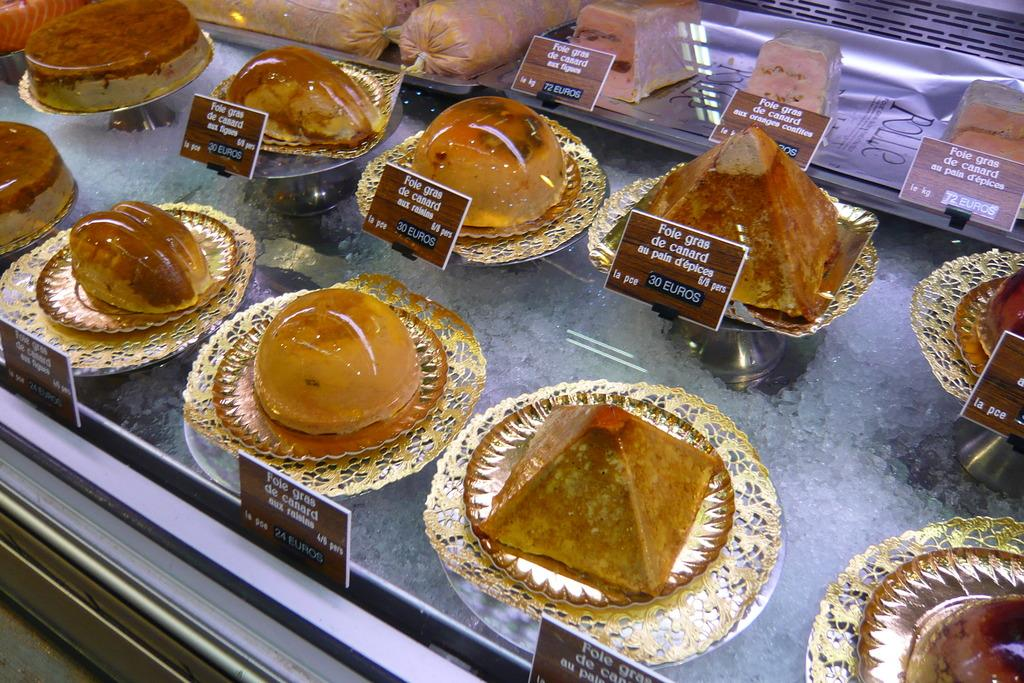What type of objects are present in the image? There are food items in the image. How are the food items arranged in the image? The food items are in plates. Where are the plates located in the image? The plates are in the center of the image. What book is being read by the food items in the image? There are no books or reading activities depicted in the image; it features food items in plates. 